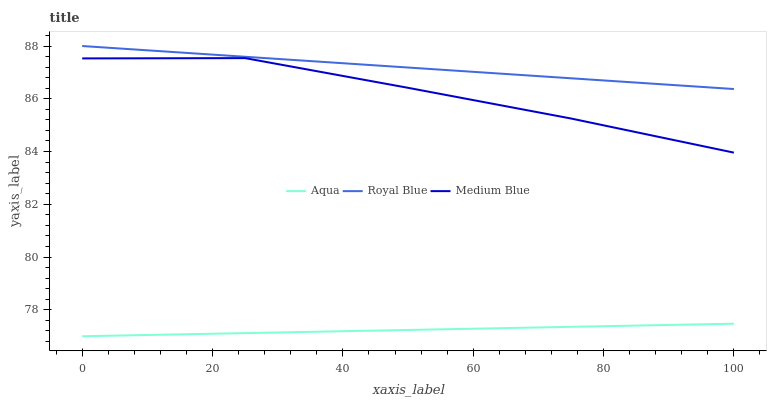Does Medium Blue have the minimum area under the curve?
Answer yes or no. No. Does Medium Blue have the maximum area under the curve?
Answer yes or no. No. Is Medium Blue the smoothest?
Answer yes or no. No. Is Aqua the roughest?
Answer yes or no. No. Does Medium Blue have the lowest value?
Answer yes or no. No. Does Medium Blue have the highest value?
Answer yes or no. No. Is Aqua less than Medium Blue?
Answer yes or no. Yes. Is Royal Blue greater than Aqua?
Answer yes or no. Yes. Does Aqua intersect Medium Blue?
Answer yes or no. No. 